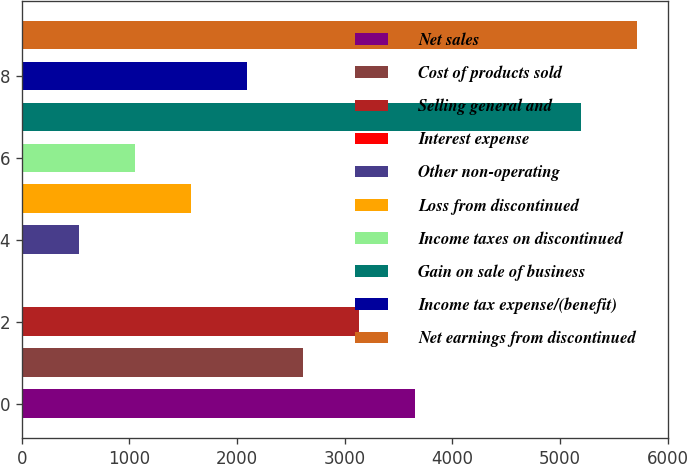Convert chart to OTSL. <chart><loc_0><loc_0><loc_500><loc_500><bar_chart><fcel>Net sales<fcel>Cost of products sold<fcel>Selling general and<fcel>Interest expense<fcel>Other non-operating<fcel>Loss from discontinued<fcel>Income taxes on discontinued<fcel>Gain on sale of business<fcel>Income tax expense/(benefit)<fcel>Net earnings from discontinued<nl><fcel>3656.1<fcel>2615.5<fcel>3135.8<fcel>14<fcel>534.3<fcel>1574.9<fcel>1054.6<fcel>5197<fcel>2095.2<fcel>5717.3<nl></chart> 